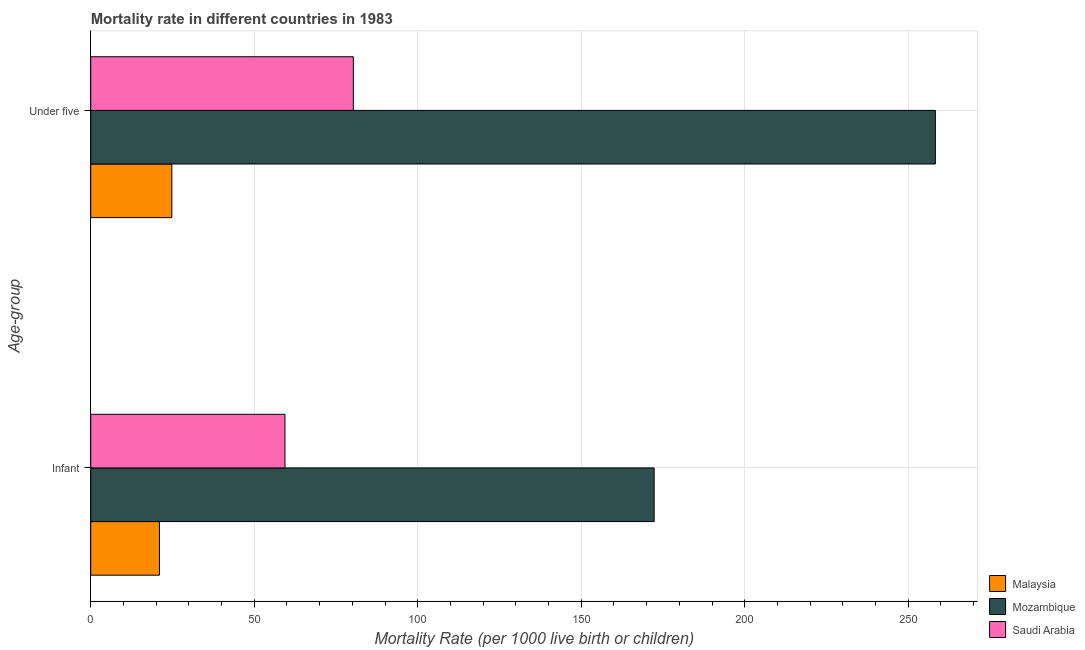How many different coloured bars are there?
Offer a very short reply. 3. How many groups of bars are there?
Offer a very short reply. 2. Are the number of bars per tick equal to the number of legend labels?
Offer a very short reply. Yes. Are the number of bars on each tick of the Y-axis equal?
Your response must be concise. Yes. How many bars are there on the 1st tick from the bottom?
Give a very brief answer. 3. What is the label of the 1st group of bars from the top?
Your answer should be very brief. Under five. Across all countries, what is the maximum under-5 mortality rate?
Offer a very short reply. 258.3. Across all countries, what is the minimum under-5 mortality rate?
Your answer should be compact. 24.8. In which country was the infant mortality rate maximum?
Offer a very short reply. Mozambique. In which country was the under-5 mortality rate minimum?
Provide a succinct answer. Malaysia. What is the total infant mortality rate in the graph?
Ensure brevity in your answer.  252.7. What is the difference between the infant mortality rate in Mozambique and that in Saudi Arabia?
Offer a terse response. 112.9. What is the difference between the infant mortality rate in Malaysia and the under-5 mortality rate in Saudi Arabia?
Provide a succinct answer. -59.3. What is the average infant mortality rate per country?
Offer a terse response. 84.23. What is the difference between the under-5 mortality rate and infant mortality rate in Saudi Arabia?
Offer a terse response. 20.9. What is the ratio of the under-5 mortality rate in Malaysia to that in Saudi Arabia?
Your answer should be compact. 0.31. Is the under-5 mortality rate in Saudi Arabia less than that in Malaysia?
Make the answer very short. No. In how many countries, is the infant mortality rate greater than the average infant mortality rate taken over all countries?
Your response must be concise. 1. What does the 1st bar from the top in Infant represents?
Give a very brief answer. Saudi Arabia. What does the 3rd bar from the bottom in Under five represents?
Make the answer very short. Saudi Arabia. How many bars are there?
Make the answer very short. 6. Are the values on the major ticks of X-axis written in scientific E-notation?
Your answer should be compact. No. How are the legend labels stacked?
Provide a succinct answer. Vertical. What is the title of the graph?
Give a very brief answer. Mortality rate in different countries in 1983. Does "Bangladesh" appear as one of the legend labels in the graph?
Keep it short and to the point. No. What is the label or title of the X-axis?
Your answer should be compact. Mortality Rate (per 1000 live birth or children). What is the label or title of the Y-axis?
Your response must be concise. Age-group. What is the Mortality Rate (per 1000 live birth or children) in Mozambique in Infant?
Make the answer very short. 172.3. What is the Mortality Rate (per 1000 live birth or children) of Saudi Arabia in Infant?
Offer a terse response. 59.4. What is the Mortality Rate (per 1000 live birth or children) of Malaysia in Under five?
Your response must be concise. 24.8. What is the Mortality Rate (per 1000 live birth or children) in Mozambique in Under five?
Keep it short and to the point. 258.3. What is the Mortality Rate (per 1000 live birth or children) in Saudi Arabia in Under five?
Ensure brevity in your answer.  80.3. Across all Age-group, what is the maximum Mortality Rate (per 1000 live birth or children) of Malaysia?
Provide a succinct answer. 24.8. Across all Age-group, what is the maximum Mortality Rate (per 1000 live birth or children) of Mozambique?
Give a very brief answer. 258.3. Across all Age-group, what is the maximum Mortality Rate (per 1000 live birth or children) in Saudi Arabia?
Provide a succinct answer. 80.3. Across all Age-group, what is the minimum Mortality Rate (per 1000 live birth or children) of Mozambique?
Your answer should be compact. 172.3. Across all Age-group, what is the minimum Mortality Rate (per 1000 live birth or children) in Saudi Arabia?
Offer a terse response. 59.4. What is the total Mortality Rate (per 1000 live birth or children) of Malaysia in the graph?
Your answer should be compact. 45.8. What is the total Mortality Rate (per 1000 live birth or children) of Mozambique in the graph?
Give a very brief answer. 430.6. What is the total Mortality Rate (per 1000 live birth or children) in Saudi Arabia in the graph?
Give a very brief answer. 139.7. What is the difference between the Mortality Rate (per 1000 live birth or children) in Mozambique in Infant and that in Under five?
Provide a short and direct response. -86. What is the difference between the Mortality Rate (per 1000 live birth or children) in Saudi Arabia in Infant and that in Under five?
Offer a terse response. -20.9. What is the difference between the Mortality Rate (per 1000 live birth or children) in Malaysia in Infant and the Mortality Rate (per 1000 live birth or children) in Mozambique in Under five?
Provide a short and direct response. -237.3. What is the difference between the Mortality Rate (per 1000 live birth or children) in Malaysia in Infant and the Mortality Rate (per 1000 live birth or children) in Saudi Arabia in Under five?
Your answer should be compact. -59.3. What is the difference between the Mortality Rate (per 1000 live birth or children) in Mozambique in Infant and the Mortality Rate (per 1000 live birth or children) in Saudi Arabia in Under five?
Your answer should be very brief. 92. What is the average Mortality Rate (per 1000 live birth or children) of Malaysia per Age-group?
Give a very brief answer. 22.9. What is the average Mortality Rate (per 1000 live birth or children) of Mozambique per Age-group?
Keep it short and to the point. 215.3. What is the average Mortality Rate (per 1000 live birth or children) of Saudi Arabia per Age-group?
Provide a succinct answer. 69.85. What is the difference between the Mortality Rate (per 1000 live birth or children) of Malaysia and Mortality Rate (per 1000 live birth or children) of Mozambique in Infant?
Provide a short and direct response. -151.3. What is the difference between the Mortality Rate (per 1000 live birth or children) of Malaysia and Mortality Rate (per 1000 live birth or children) of Saudi Arabia in Infant?
Keep it short and to the point. -38.4. What is the difference between the Mortality Rate (per 1000 live birth or children) of Mozambique and Mortality Rate (per 1000 live birth or children) of Saudi Arabia in Infant?
Ensure brevity in your answer.  112.9. What is the difference between the Mortality Rate (per 1000 live birth or children) in Malaysia and Mortality Rate (per 1000 live birth or children) in Mozambique in Under five?
Give a very brief answer. -233.5. What is the difference between the Mortality Rate (per 1000 live birth or children) in Malaysia and Mortality Rate (per 1000 live birth or children) in Saudi Arabia in Under five?
Give a very brief answer. -55.5. What is the difference between the Mortality Rate (per 1000 live birth or children) of Mozambique and Mortality Rate (per 1000 live birth or children) of Saudi Arabia in Under five?
Ensure brevity in your answer.  178. What is the ratio of the Mortality Rate (per 1000 live birth or children) of Malaysia in Infant to that in Under five?
Provide a succinct answer. 0.85. What is the ratio of the Mortality Rate (per 1000 live birth or children) in Mozambique in Infant to that in Under five?
Provide a succinct answer. 0.67. What is the ratio of the Mortality Rate (per 1000 live birth or children) of Saudi Arabia in Infant to that in Under five?
Give a very brief answer. 0.74. What is the difference between the highest and the second highest Mortality Rate (per 1000 live birth or children) of Saudi Arabia?
Give a very brief answer. 20.9. What is the difference between the highest and the lowest Mortality Rate (per 1000 live birth or children) of Malaysia?
Your answer should be very brief. 3.8. What is the difference between the highest and the lowest Mortality Rate (per 1000 live birth or children) in Mozambique?
Provide a short and direct response. 86. What is the difference between the highest and the lowest Mortality Rate (per 1000 live birth or children) in Saudi Arabia?
Offer a very short reply. 20.9. 